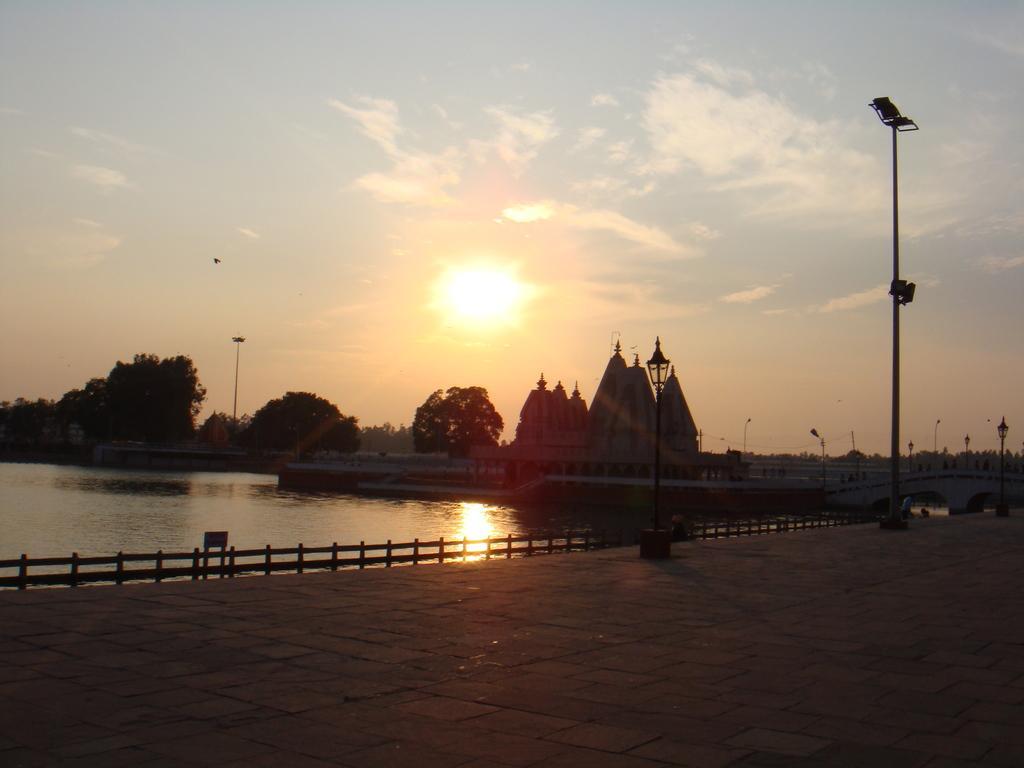Please provide a concise description of this image. In this image in front there is a road. There are street lights. There is a wooden fence. In the center of the image there is water. There is a temple. In the background of the image there are trees. There is the sun and there is sky. 